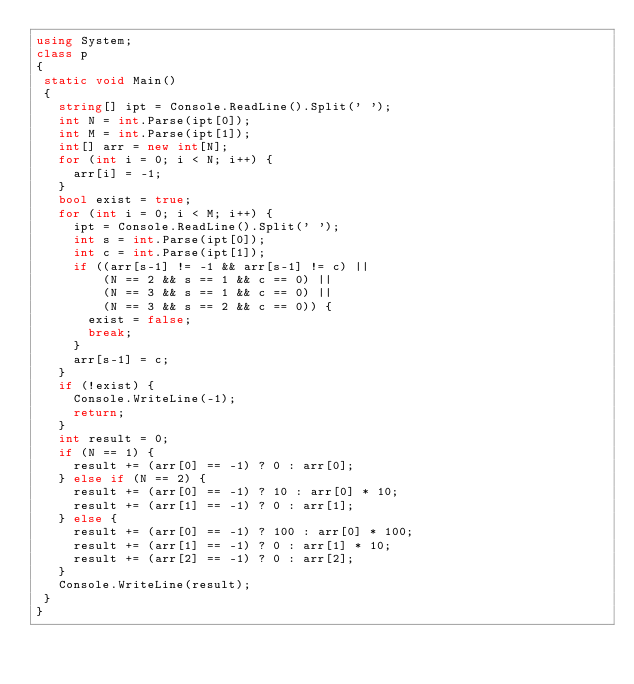Convert code to text. <code><loc_0><loc_0><loc_500><loc_500><_C#_>using System;
class p
{
 static void Main()
 {
   string[] ipt = Console.ReadLine().Split(' ');
   int N = int.Parse(ipt[0]);
   int M = int.Parse(ipt[1]);
   int[] arr = new int[N];
   for (int i = 0; i < N; i++) {
     arr[i] = -1;
   }
   bool exist = true;
   for (int i = 0; i < M; i++) {
     ipt = Console.ReadLine().Split(' ');
     int s = int.Parse(ipt[0]);
     int c = int.Parse(ipt[1]);
     if ((arr[s-1] != -1 && arr[s-1] != c) ||
         (N == 2 && s == 1 && c == 0) ||
         (N == 3 && s == 1 && c == 0) ||
         (N == 3 && s == 2 && c == 0)) {
       exist = false;
       break;
     }
     arr[s-1] = c;
   }
   if (!exist) {
     Console.WriteLine(-1);
     return;
   }
   int result = 0;
   if (N == 1) {
     result += (arr[0] == -1) ? 0 : arr[0];
   } else if (N == 2) {
     result += (arr[0] == -1) ? 10 : arr[0] * 10;
     result += (arr[1] == -1) ? 0 : arr[1];
   } else {
     result += (arr[0] == -1) ? 100 : arr[0] * 100;
     result += (arr[1] == -1) ? 0 : arr[1] * 10;
     result += (arr[2] == -1) ? 0 : arr[2];
   }
   Console.WriteLine(result);
 }
}</code> 